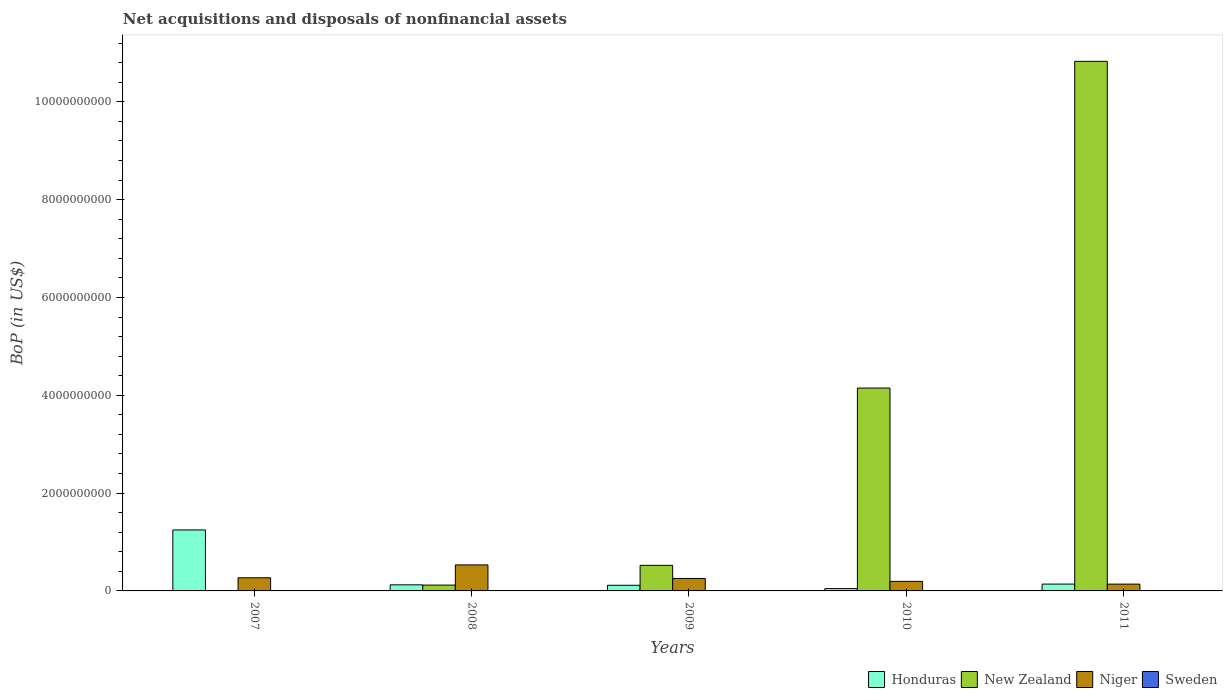How many groups of bars are there?
Give a very brief answer. 5. Are the number of bars per tick equal to the number of legend labels?
Offer a very short reply. No. How many bars are there on the 4th tick from the right?
Give a very brief answer. 3. What is the label of the 2nd group of bars from the left?
Your answer should be compact. 2008. In how many cases, is the number of bars for a given year not equal to the number of legend labels?
Offer a very short reply. 5. What is the Balance of Payments in Niger in 2011?
Provide a succinct answer. 1.39e+08. Across all years, what is the maximum Balance of Payments in New Zealand?
Your response must be concise. 1.08e+1. Across all years, what is the minimum Balance of Payments in New Zealand?
Offer a very short reply. 7.64e+05. What is the total Balance of Payments in New Zealand in the graph?
Your answer should be very brief. 1.56e+1. What is the difference between the Balance of Payments in New Zealand in 2010 and that in 2011?
Keep it short and to the point. -6.68e+09. What is the difference between the Balance of Payments in Honduras in 2008 and the Balance of Payments in New Zealand in 2007?
Provide a succinct answer. 1.24e+08. What is the average Balance of Payments in Sweden per year?
Provide a short and direct response. 0. In the year 2008, what is the difference between the Balance of Payments in Honduras and Balance of Payments in New Zealand?
Offer a very short reply. 4.89e+06. In how many years, is the Balance of Payments in Niger greater than 3200000000 US$?
Offer a terse response. 0. What is the ratio of the Balance of Payments in Niger in 2008 to that in 2009?
Offer a terse response. 2.09. Is the Balance of Payments in Honduras in 2009 less than that in 2010?
Offer a terse response. No. Is the difference between the Balance of Payments in Honduras in 2010 and 2011 greater than the difference between the Balance of Payments in New Zealand in 2010 and 2011?
Your response must be concise. Yes. What is the difference between the highest and the second highest Balance of Payments in Honduras?
Offer a terse response. 1.11e+09. What is the difference between the highest and the lowest Balance of Payments in New Zealand?
Your answer should be compact. 1.08e+1. Is the sum of the Balance of Payments in Honduras in 2008 and 2010 greater than the maximum Balance of Payments in Niger across all years?
Keep it short and to the point. No. Is it the case that in every year, the sum of the Balance of Payments in Niger and Balance of Payments in Honduras is greater than the sum of Balance of Payments in Sweden and Balance of Payments in New Zealand?
Your answer should be very brief. No. How many bars are there?
Your answer should be very brief. 15. Are all the bars in the graph horizontal?
Give a very brief answer. No. How many years are there in the graph?
Provide a succinct answer. 5. Are the values on the major ticks of Y-axis written in scientific E-notation?
Provide a succinct answer. No. Does the graph contain grids?
Provide a succinct answer. No. What is the title of the graph?
Make the answer very short. Net acquisitions and disposals of nonfinancial assets. What is the label or title of the X-axis?
Your answer should be very brief. Years. What is the label or title of the Y-axis?
Keep it short and to the point. BoP (in US$). What is the BoP (in US$) of Honduras in 2007?
Provide a succinct answer. 1.25e+09. What is the BoP (in US$) of New Zealand in 2007?
Provide a succinct answer. 7.64e+05. What is the BoP (in US$) of Niger in 2007?
Your response must be concise. 2.69e+08. What is the BoP (in US$) in Honduras in 2008?
Make the answer very short. 1.24e+08. What is the BoP (in US$) in New Zealand in 2008?
Offer a terse response. 1.19e+08. What is the BoP (in US$) of Niger in 2008?
Your answer should be very brief. 5.32e+08. What is the BoP (in US$) in Honduras in 2009?
Keep it short and to the point. 1.15e+08. What is the BoP (in US$) in New Zealand in 2009?
Provide a succinct answer. 5.23e+08. What is the BoP (in US$) in Niger in 2009?
Ensure brevity in your answer.  2.55e+08. What is the BoP (in US$) in Sweden in 2009?
Your response must be concise. 0. What is the BoP (in US$) in Honduras in 2010?
Ensure brevity in your answer.  4.76e+07. What is the BoP (in US$) in New Zealand in 2010?
Your answer should be compact. 4.15e+09. What is the BoP (in US$) in Niger in 2010?
Your answer should be very brief. 1.96e+08. What is the BoP (in US$) of Honduras in 2011?
Your answer should be very brief. 1.40e+08. What is the BoP (in US$) of New Zealand in 2011?
Provide a succinct answer. 1.08e+1. What is the BoP (in US$) of Niger in 2011?
Offer a very short reply. 1.39e+08. Across all years, what is the maximum BoP (in US$) in Honduras?
Make the answer very short. 1.25e+09. Across all years, what is the maximum BoP (in US$) of New Zealand?
Your response must be concise. 1.08e+1. Across all years, what is the maximum BoP (in US$) in Niger?
Offer a very short reply. 5.32e+08. Across all years, what is the minimum BoP (in US$) of Honduras?
Ensure brevity in your answer.  4.76e+07. Across all years, what is the minimum BoP (in US$) of New Zealand?
Provide a succinct answer. 7.64e+05. Across all years, what is the minimum BoP (in US$) of Niger?
Provide a short and direct response. 1.39e+08. What is the total BoP (in US$) in Honduras in the graph?
Your answer should be very brief. 1.67e+09. What is the total BoP (in US$) in New Zealand in the graph?
Provide a succinct answer. 1.56e+1. What is the total BoP (in US$) of Niger in the graph?
Ensure brevity in your answer.  1.39e+09. What is the difference between the BoP (in US$) in Honduras in 2007 and that in 2008?
Provide a short and direct response. 1.12e+09. What is the difference between the BoP (in US$) of New Zealand in 2007 and that in 2008?
Offer a very short reply. -1.19e+08. What is the difference between the BoP (in US$) in Niger in 2007 and that in 2008?
Make the answer very short. -2.63e+08. What is the difference between the BoP (in US$) in Honduras in 2007 and that in 2009?
Your answer should be compact. 1.13e+09. What is the difference between the BoP (in US$) of New Zealand in 2007 and that in 2009?
Your answer should be very brief. -5.22e+08. What is the difference between the BoP (in US$) of Niger in 2007 and that in 2009?
Offer a very short reply. 1.39e+07. What is the difference between the BoP (in US$) of Honduras in 2007 and that in 2010?
Make the answer very short. 1.20e+09. What is the difference between the BoP (in US$) of New Zealand in 2007 and that in 2010?
Provide a succinct answer. -4.15e+09. What is the difference between the BoP (in US$) of Niger in 2007 and that in 2010?
Offer a very short reply. 7.30e+07. What is the difference between the BoP (in US$) of Honduras in 2007 and that in 2011?
Your answer should be very brief. 1.11e+09. What is the difference between the BoP (in US$) of New Zealand in 2007 and that in 2011?
Keep it short and to the point. -1.08e+1. What is the difference between the BoP (in US$) in Niger in 2007 and that in 2011?
Ensure brevity in your answer.  1.30e+08. What is the difference between the BoP (in US$) of Honduras in 2008 and that in 2009?
Offer a very short reply. 9.15e+06. What is the difference between the BoP (in US$) of New Zealand in 2008 and that in 2009?
Your answer should be compact. -4.03e+08. What is the difference between the BoP (in US$) of Niger in 2008 and that in 2009?
Offer a very short reply. 2.77e+08. What is the difference between the BoP (in US$) in Honduras in 2008 and that in 2010?
Your response must be concise. 7.68e+07. What is the difference between the BoP (in US$) in New Zealand in 2008 and that in 2010?
Ensure brevity in your answer.  -4.03e+09. What is the difference between the BoP (in US$) of Niger in 2008 and that in 2010?
Provide a short and direct response. 3.36e+08. What is the difference between the BoP (in US$) in Honduras in 2008 and that in 2011?
Your answer should be very brief. -1.53e+07. What is the difference between the BoP (in US$) in New Zealand in 2008 and that in 2011?
Provide a short and direct response. -1.07e+1. What is the difference between the BoP (in US$) of Niger in 2008 and that in 2011?
Provide a succinct answer. 3.93e+08. What is the difference between the BoP (in US$) in Honduras in 2009 and that in 2010?
Provide a short and direct response. 6.76e+07. What is the difference between the BoP (in US$) of New Zealand in 2009 and that in 2010?
Offer a very short reply. -3.62e+09. What is the difference between the BoP (in US$) in Niger in 2009 and that in 2010?
Offer a very short reply. 5.91e+07. What is the difference between the BoP (in US$) of Honduras in 2009 and that in 2011?
Provide a short and direct response. -2.44e+07. What is the difference between the BoP (in US$) in New Zealand in 2009 and that in 2011?
Keep it short and to the point. -1.03e+1. What is the difference between the BoP (in US$) of Niger in 2009 and that in 2011?
Give a very brief answer. 1.16e+08. What is the difference between the BoP (in US$) of Honduras in 2010 and that in 2011?
Provide a succinct answer. -9.20e+07. What is the difference between the BoP (in US$) of New Zealand in 2010 and that in 2011?
Offer a very short reply. -6.68e+09. What is the difference between the BoP (in US$) in Niger in 2010 and that in 2011?
Your answer should be compact. 5.66e+07. What is the difference between the BoP (in US$) in Honduras in 2007 and the BoP (in US$) in New Zealand in 2008?
Offer a very short reply. 1.13e+09. What is the difference between the BoP (in US$) of Honduras in 2007 and the BoP (in US$) of Niger in 2008?
Your answer should be compact. 7.15e+08. What is the difference between the BoP (in US$) in New Zealand in 2007 and the BoP (in US$) in Niger in 2008?
Ensure brevity in your answer.  -5.31e+08. What is the difference between the BoP (in US$) in Honduras in 2007 and the BoP (in US$) in New Zealand in 2009?
Keep it short and to the point. 7.24e+08. What is the difference between the BoP (in US$) of Honduras in 2007 and the BoP (in US$) of Niger in 2009?
Provide a succinct answer. 9.92e+08. What is the difference between the BoP (in US$) in New Zealand in 2007 and the BoP (in US$) in Niger in 2009?
Your response must be concise. -2.54e+08. What is the difference between the BoP (in US$) in Honduras in 2007 and the BoP (in US$) in New Zealand in 2010?
Your response must be concise. -2.90e+09. What is the difference between the BoP (in US$) of Honduras in 2007 and the BoP (in US$) of Niger in 2010?
Give a very brief answer. 1.05e+09. What is the difference between the BoP (in US$) of New Zealand in 2007 and the BoP (in US$) of Niger in 2010?
Your answer should be very brief. -1.95e+08. What is the difference between the BoP (in US$) in Honduras in 2007 and the BoP (in US$) in New Zealand in 2011?
Make the answer very short. -9.58e+09. What is the difference between the BoP (in US$) of Honduras in 2007 and the BoP (in US$) of Niger in 2011?
Ensure brevity in your answer.  1.11e+09. What is the difference between the BoP (in US$) in New Zealand in 2007 and the BoP (in US$) in Niger in 2011?
Make the answer very short. -1.38e+08. What is the difference between the BoP (in US$) of Honduras in 2008 and the BoP (in US$) of New Zealand in 2009?
Provide a succinct answer. -3.99e+08. What is the difference between the BoP (in US$) of Honduras in 2008 and the BoP (in US$) of Niger in 2009?
Ensure brevity in your answer.  -1.31e+08. What is the difference between the BoP (in US$) of New Zealand in 2008 and the BoP (in US$) of Niger in 2009?
Provide a short and direct response. -1.35e+08. What is the difference between the BoP (in US$) of Honduras in 2008 and the BoP (in US$) of New Zealand in 2010?
Your answer should be compact. -4.02e+09. What is the difference between the BoP (in US$) in Honduras in 2008 and the BoP (in US$) in Niger in 2010?
Your response must be concise. -7.15e+07. What is the difference between the BoP (in US$) in New Zealand in 2008 and the BoP (in US$) in Niger in 2010?
Keep it short and to the point. -7.64e+07. What is the difference between the BoP (in US$) in Honduras in 2008 and the BoP (in US$) in New Zealand in 2011?
Offer a terse response. -1.07e+1. What is the difference between the BoP (in US$) in Honduras in 2008 and the BoP (in US$) in Niger in 2011?
Provide a succinct answer. -1.49e+07. What is the difference between the BoP (in US$) of New Zealand in 2008 and the BoP (in US$) of Niger in 2011?
Provide a succinct answer. -1.98e+07. What is the difference between the BoP (in US$) in Honduras in 2009 and the BoP (in US$) in New Zealand in 2010?
Make the answer very short. -4.03e+09. What is the difference between the BoP (in US$) of Honduras in 2009 and the BoP (in US$) of Niger in 2010?
Offer a very short reply. -8.06e+07. What is the difference between the BoP (in US$) in New Zealand in 2009 and the BoP (in US$) in Niger in 2010?
Offer a very short reply. 3.27e+08. What is the difference between the BoP (in US$) in Honduras in 2009 and the BoP (in US$) in New Zealand in 2011?
Offer a terse response. -1.07e+1. What is the difference between the BoP (in US$) in Honduras in 2009 and the BoP (in US$) in Niger in 2011?
Offer a terse response. -2.40e+07. What is the difference between the BoP (in US$) in New Zealand in 2009 and the BoP (in US$) in Niger in 2011?
Ensure brevity in your answer.  3.84e+08. What is the difference between the BoP (in US$) of Honduras in 2010 and the BoP (in US$) of New Zealand in 2011?
Provide a short and direct response. -1.08e+1. What is the difference between the BoP (in US$) of Honduras in 2010 and the BoP (in US$) of Niger in 2011?
Make the answer very short. -9.16e+07. What is the difference between the BoP (in US$) of New Zealand in 2010 and the BoP (in US$) of Niger in 2011?
Offer a very short reply. 4.01e+09. What is the average BoP (in US$) of Honduras per year?
Your response must be concise. 3.35e+08. What is the average BoP (in US$) in New Zealand per year?
Give a very brief answer. 3.12e+09. What is the average BoP (in US$) of Niger per year?
Give a very brief answer. 2.78e+08. What is the average BoP (in US$) of Sweden per year?
Make the answer very short. 0. In the year 2007, what is the difference between the BoP (in US$) in Honduras and BoP (in US$) in New Zealand?
Make the answer very short. 1.25e+09. In the year 2007, what is the difference between the BoP (in US$) in Honduras and BoP (in US$) in Niger?
Your answer should be compact. 9.78e+08. In the year 2007, what is the difference between the BoP (in US$) in New Zealand and BoP (in US$) in Niger?
Offer a very short reply. -2.68e+08. In the year 2008, what is the difference between the BoP (in US$) of Honduras and BoP (in US$) of New Zealand?
Your answer should be very brief. 4.89e+06. In the year 2008, what is the difference between the BoP (in US$) in Honduras and BoP (in US$) in Niger?
Give a very brief answer. -4.08e+08. In the year 2008, what is the difference between the BoP (in US$) of New Zealand and BoP (in US$) of Niger?
Offer a terse response. -4.13e+08. In the year 2009, what is the difference between the BoP (in US$) of Honduras and BoP (in US$) of New Zealand?
Ensure brevity in your answer.  -4.08e+08. In the year 2009, what is the difference between the BoP (in US$) in Honduras and BoP (in US$) in Niger?
Provide a short and direct response. -1.40e+08. In the year 2009, what is the difference between the BoP (in US$) in New Zealand and BoP (in US$) in Niger?
Give a very brief answer. 2.68e+08. In the year 2010, what is the difference between the BoP (in US$) in Honduras and BoP (in US$) in New Zealand?
Provide a succinct answer. -4.10e+09. In the year 2010, what is the difference between the BoP (in US$) in Honduras and BoP (in US$) in Niger?
Your answer should be compact. -1.48e+08. In the year 2010, what is the difference between the BoP (in US$) in New Zealand and BoP (in US$) in Niger?
Keep it short and to the point. 3.95e+09. In the year 2011, what is the difference between the BoP (in US$) of Honduras and BoP (in US$) of New Zealand?
Your answer should be very brief. -1.07e+1. In the year 2011, what is the difference between the BoP (in US$) of Honduras and BoP (in US$) of Niger?
Provide a succinct answer. 3.98e+05. In the year 2011, what is the difference between the BoP (in US$) in New Zealand and BoP (in US$) in Niger?
Offer a very short reply. 1.07e+1. What is the ratio of the BoP (in US$) of Honduras in 2007 to that in 2008?
Offer a very short reply. 10.03. What is the ratio of the BoP (in US$) in New Zealand in 2007 to that in 2008?
Your response must be concise. 0.01. What is the ratio of the BoP (in US$) of Niger in 2007 to that in 2008?
Make the answer very short. 0.51. What is the ratio of the BoP (in US$) of Honduras in 2007 to that in 2009?
Your answer should be very brief. 10.82. What is the ratio of the BoP (in US$) of New Zealand in 2007 to that in 2009?
Provide a succinct answer. 0. What is the ratio of the BoP (in US$) of Niger in 2007 to that in 2009?
Provide a short and direct response. 1.05. What is the ratio of the BoP (in US$) of Honduras in 2007 to that in 2010?
Your response must be concise. 26.21. What is the ratio of the BoP (in US$) of Niger in 2007 to that in 2010?
Ensure brevity in your answer.  1.37. What is the ratio of the BoP (in US$) of Honduras in 2007 to that in 2011?
Offer a terse response. 8.93. What is the ratio of the BoP (in US$) in New Zealand in 2007 to that in 2011?
Offer a terse response. 0. What is the ratio of the BoP (in US$) in Niger in 2007 to that in 2011?
Offer a terse response. 1.93. What is the ratio of the BoP (in US$) in Honduras in 2008 to that in 2009?
Your answer should be compact. 1.08. What is the ratio of the BoP (in US$) in New Zealand in 2008 to that in 2009?
Your answer should be compact. 0.23. What is the ratio of the BoP (in US$) of Niger in 2008 to that in 2009?
Give a very brief answer. 2.09. What is the ratio of the BoP (in US$) in Honduras in 2008 to that in 2010?
Ensure brevity in your answer.  2.61. What is the ratio of the BoP (in US$) in New Zealand in 2008 to that in 2010?
Provide a succinct answer. 0.03. What is the ratio of the BoP (in US$) of Niger in 2008 to that in 2010?
Provide a succinct answer. 2.72. What is the ratio of the BoP (in US$) of Honduras in 2008 to that in 2011?
Your answer should be compact. 0.89. What is the ratio of the BoP (in US$) of New Zealand in 2008 to that in 2011?
Make the answer very short. 0.01. What is the ratio of the BoP (in US$) of Niger in 2008 to that in 2011?
Provide a succinct answer. 3.82. What is the ratio of the BoP (in US$) in Honduras in 2009 to that in 2010?
Your response must be concise. 2.42. What is the ratio of the BoP (in US$) of New Zealand in 2009 to that in 2010?
Make the answer very short. 0.13. What is the ratio of the BoP (in US$) in Niger in 2009 to that in 2010?
Your answer should be compact. 1.3. What is the ratio of the BoP (in US$) in Honduras in 2009 to that in 2011?
Provide a succinct answer. 0.83. What is the ratio of the BoP (in US$) of New Zealand in 2009 to that in 2011?
Ensure brevity in your answer.  0.05. What is the ratio of the BoP (in US$) of Niger in 2009 to that in 2011?
Give a very brief answer. 1.83. What is the ratio of the BoP (in US$) in Honduras in 2010 to that in 2011?
Offer a terse response. 0.34. What is the ratio of the BoP (in US$) of New Zealand in 2010 to that in 2011?
Your answer should be very brief. 0.38. What is the ratio of the BoP (in US$) of Niger in 2010 to that in 2011?
Ensure brevity in your answer.  1.41. What is the difference between the highest and the second highest BoP (in US$) in Honduras?
Ensure brevity in your answer.  1.11e+09. What is the difference between the highest and the second highest BoP (in US$) of New Zealand?
Offer a terse response. 6.68e+09. What is the difference between the highest and the second highest BoP (in US$) in Niger?
Offer a terse response. 2.63e+08. What is the difference between the highest and the lowest BoP (in US$) in Honduras?
Keep it short and to the point. 1.20e+09. What is the difference between the highest and the lowest BoP (in US$) of New Zealand?
Offer a very short reply. 1.08e+1. What is the difference between the highest and the lowest BoP (in US$) in Niger?
Provide a succinct answer. 3.93e+08. 